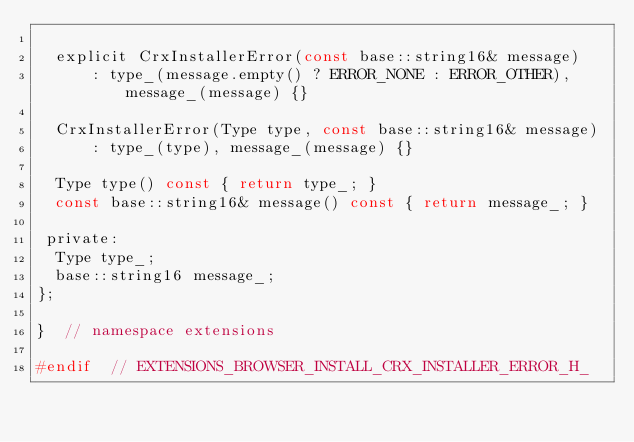Convert code to text. <code><loc_0><loc_0><loc_500><loc_500><_C_>
  explicit CrxInstallerError(const base::string16& message)
      : type_(message.empty() ? ERROR_NONE : ERROR_OTHER), message_(message) {}

  CrxInstallerError(Type type, const base::string16& message)
      : type_(type), message_(message) {}

  Type type() const { return type_; }
  const base::string16& message() const { return message_; }

 private:
  Type type_;
  base::string16 message_;
};

}  // namespace extensions

#endif  // EXTENSIONS_BROWSER_INSTALL_CRX_INSTALLER_ERROR_H_
</code> 